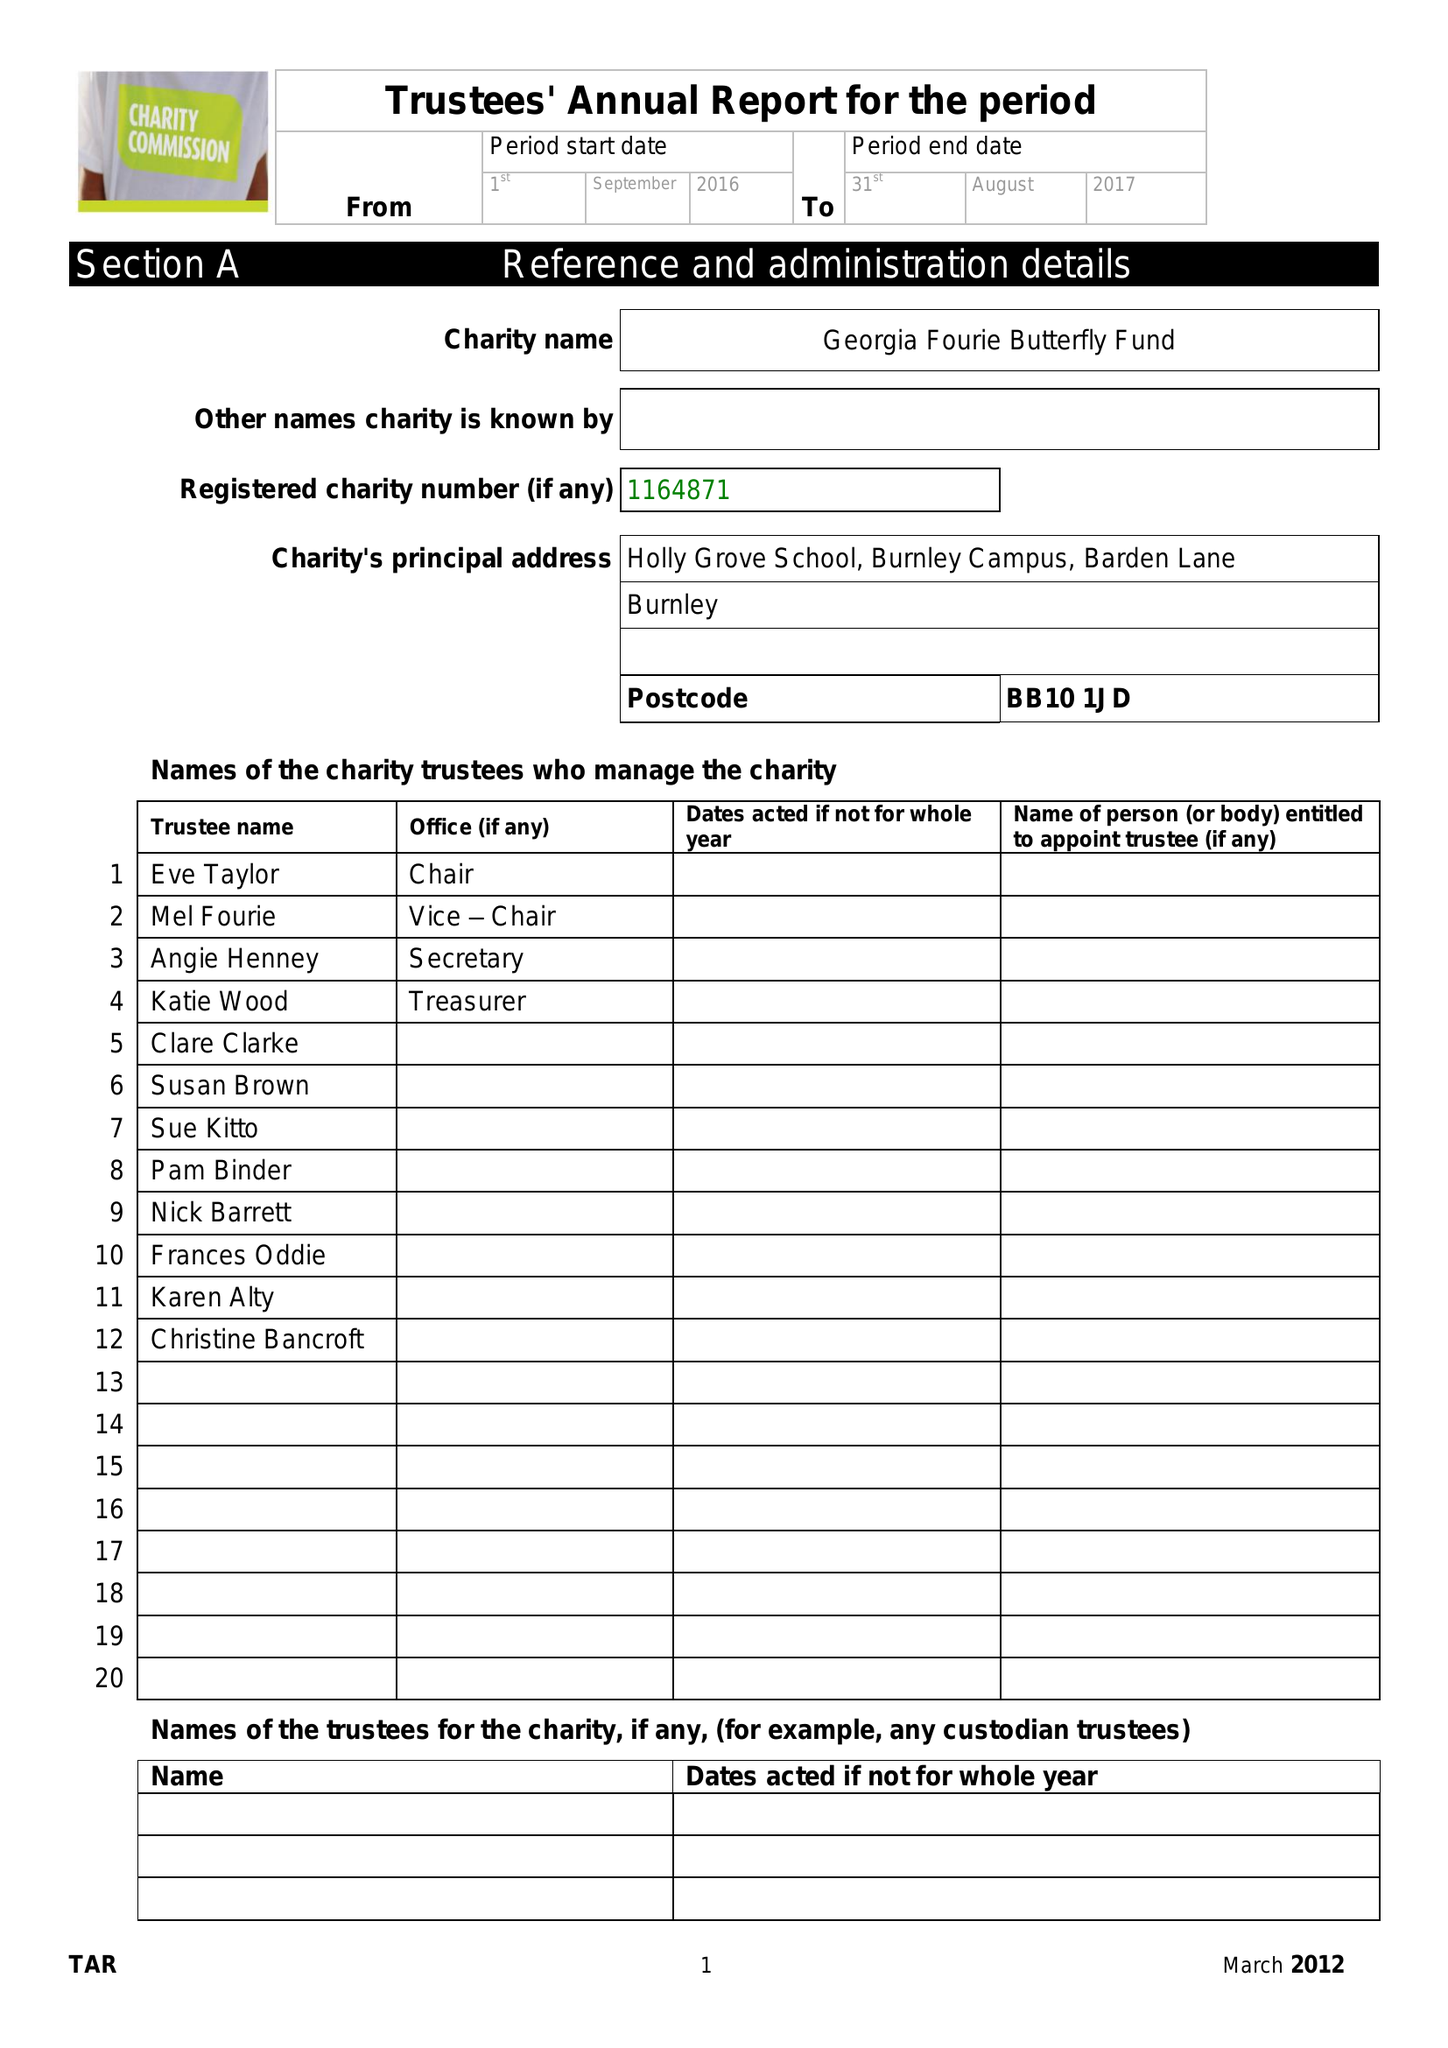What is the value for the report_date?
Answer the question using a single word or phrase. 2017-08-31 